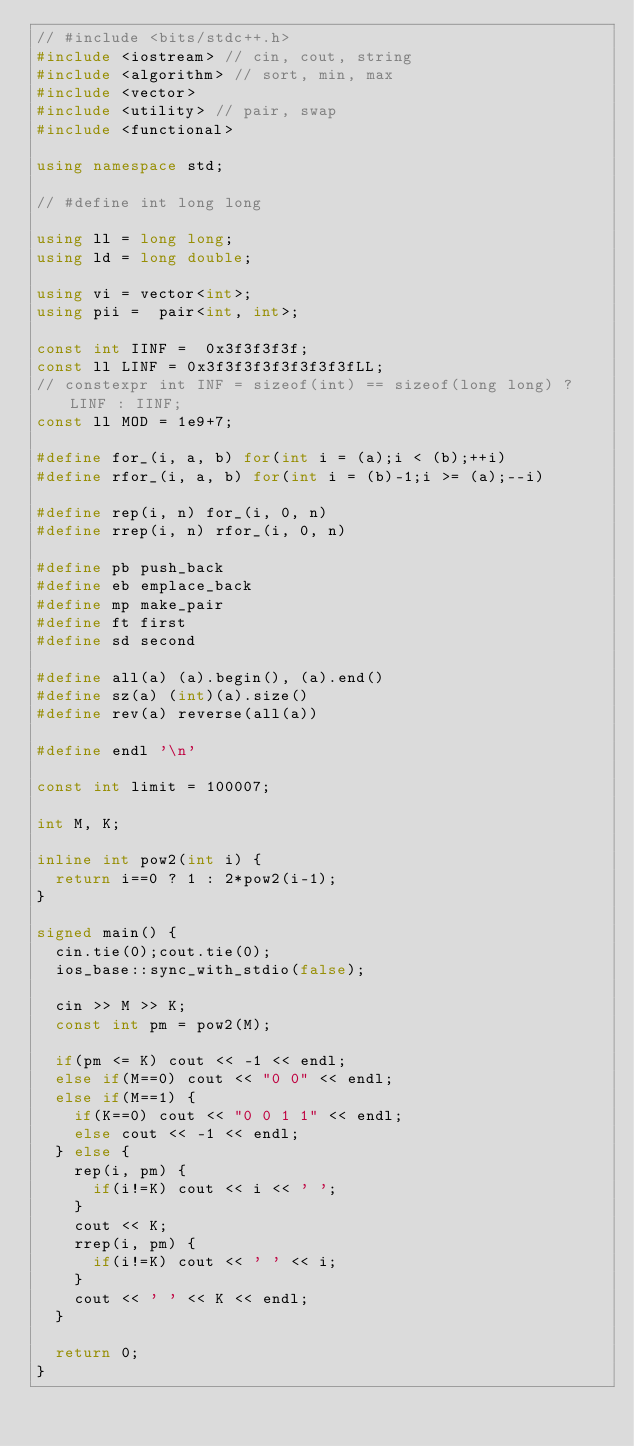<code> <loc_0><loc_0><loc_500><loc_500><_C++_>// #include <bits/stdc++.h>
#include <iostream> // cin, cout, string
#include <algorithm> // sort, min, max
#include <vector>
#include <utility> // pair, swap
#include <functional>

using namespace std;

// #define int long long

using ll = long long;
using ld = long double;

using vi = vector<int>;
using pii =  pair<int, int>;

const int IINF =  0x3f3f3f3f;
const ll LINF = 0x3f3f3f3f3f3f3f3fLL;
// constexpr int INF = sizeof(int) == sizeof(long long) ? LINF : IINF;
const ll MOD = 1e9+7;

#define for_(i, a, b) for(int i = (a);i < (b);++i)
#define rfor_(i, a, b) for(int i = (b)-1;i >= (a);--i)

#define rep(i, n) for_(i, 0, n)
#define rrep(i, n) rfor_(i, 0, n)

#define pb push_back
#define eb emplace_back
#define mp make_pair
#define ft first
#define sd second

#define all(a) (a).begin(), (a).end()
#define sz(a) (int)(a).size()
#define rev(a) reverse(all(a))

#define endl '\n'

const int limit = 100007;

int M, K;

inline int pow2(int i) {
  return i==0 ? 1 : 2*pow2(i-1);
}

signed main() {
  cin.tie(0);cout.tie(0);
  ios_base::sync_with_stdio(false);

  cin >> M >> K;
  const int pm = pow2(M);

  if(pm <= K) cout << -1 << endl;
  else if(M==0) cout << "0 0" << endl;
  else if(M==1) {
    if(K==0) cout << "0 0 1 1" << endl;
    else cout << -1 << endl;
  } else {
    rep(i, pm) {
      if(i!=K) cout << i << ' ';
    }
    cout << K;
    rrep(i, pm) {
      if(i!=K) cout << ' ' << i;
    }
    cout << ' ' << K << endl;
  }

  return 0;
}
</code> 